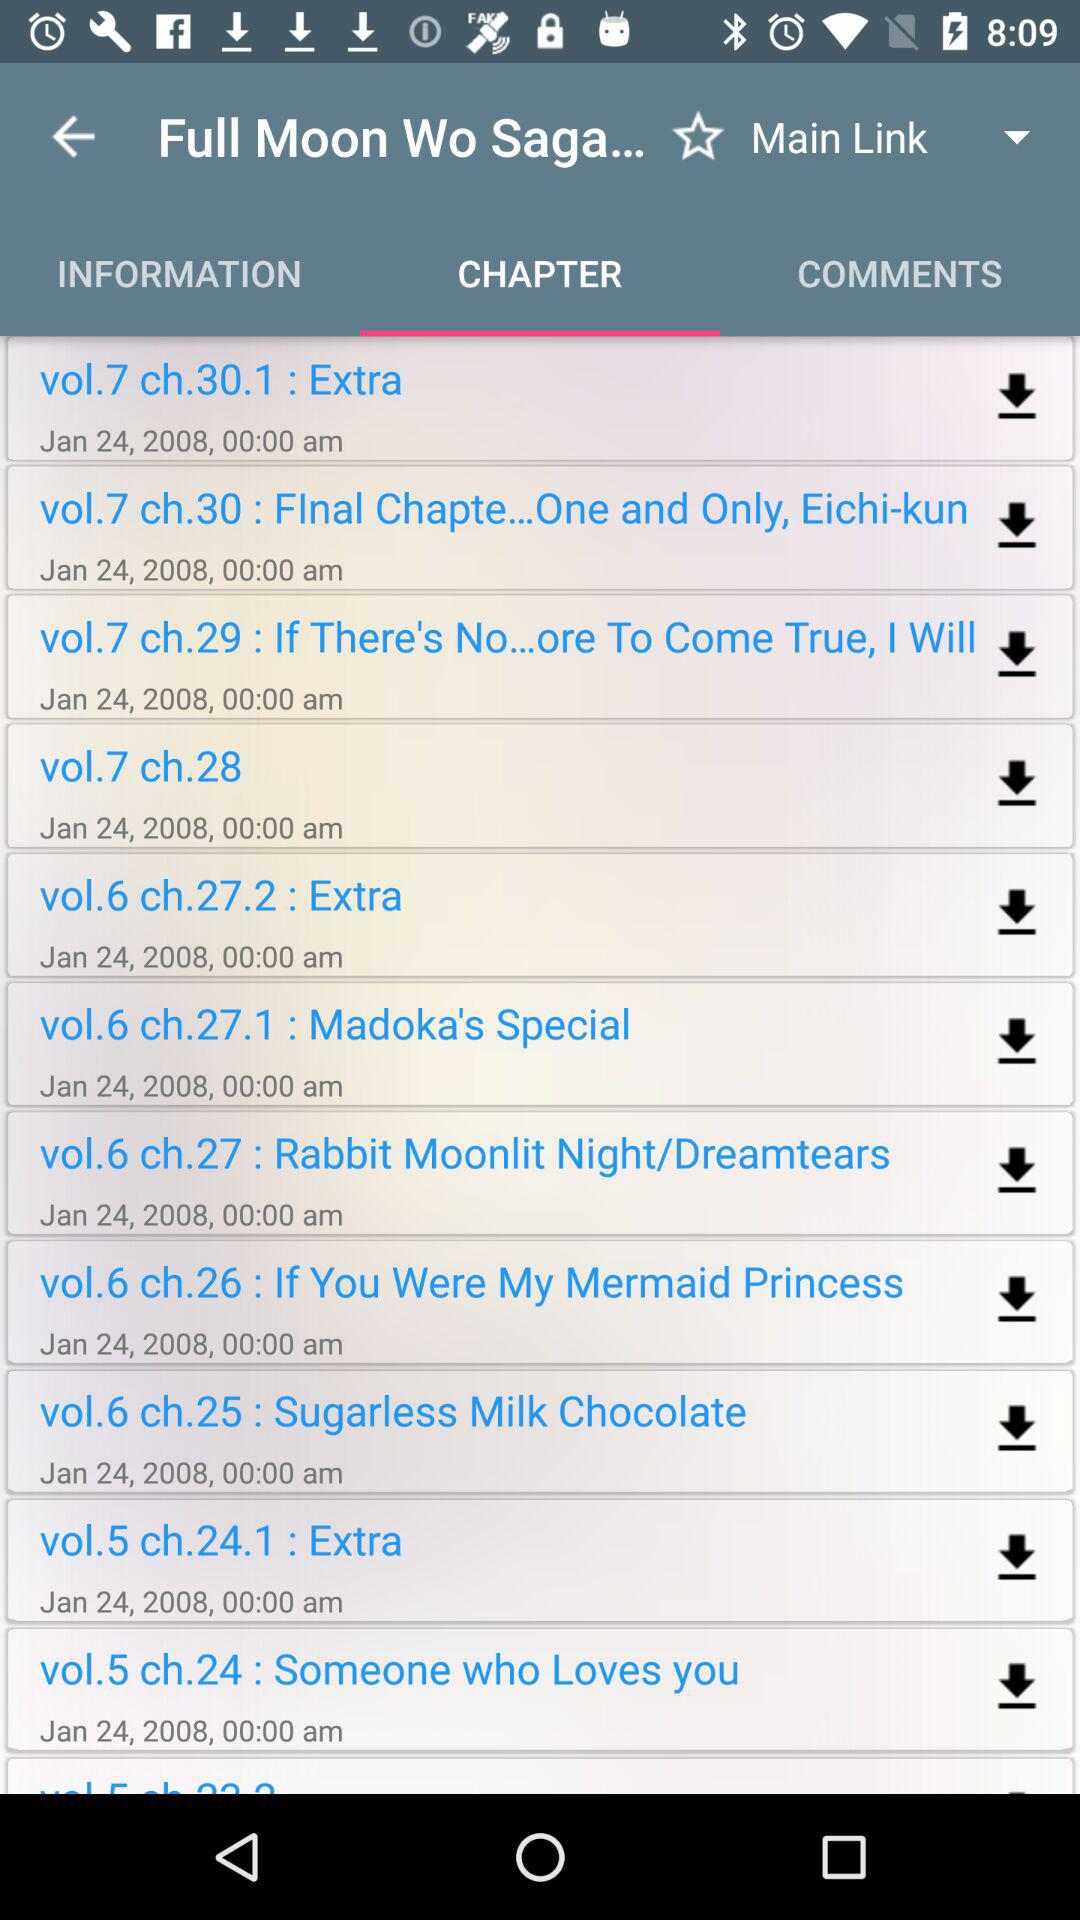At what time was vol.6 ch.27.2 : Extra uploaded? The vol.6 ch.27.2 : Extra was uploaded on January 24, 2008, at 00:00 am. 